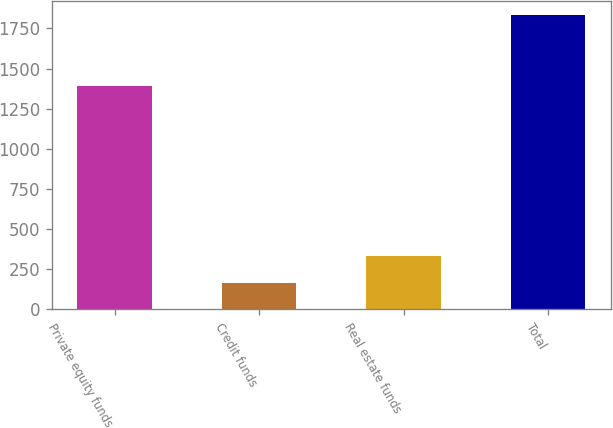Convert chart to OTSL. <chart><loc_0><loc_0><loc_500><loc_500><bar_chart><fcel>Private equity funds<fcel>Credit funds<fcel>Real estate funds<fcel>Total<nl><fcel>1393<fcel>166<fcel>332.5<fcel>1831<nl></chart> 